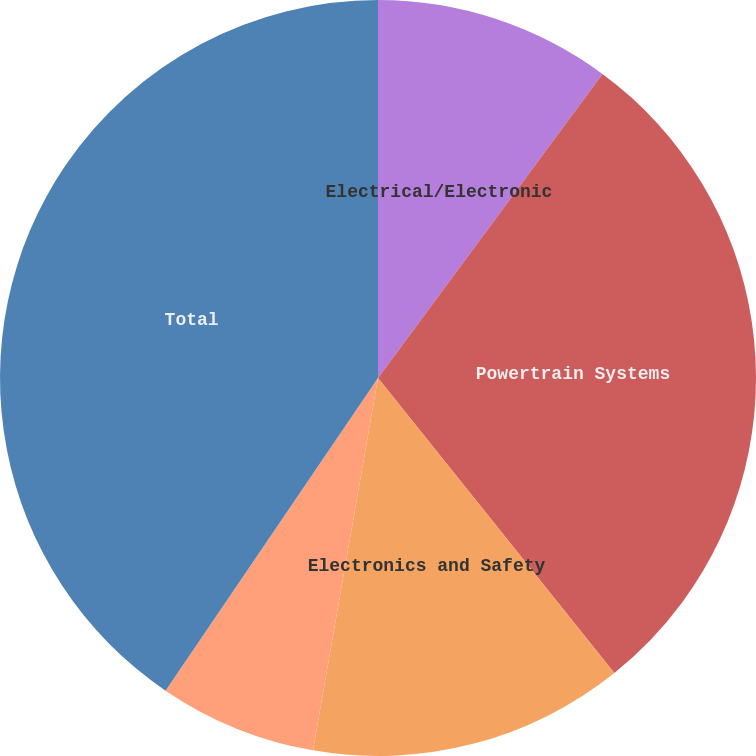Convert chart. <chart><loc_0><loc_0><loc_500><loc_500><pie_chart><fcel>Electrical/Electronic<fcel>Powertrain Systems<fcel>Electronics and Safety<fcel>Thermal Systems<fcel>Total<nl><fcel>10.12%<fcel>29.13%<fcel>13.5%<fcel>6.75%<fcel>40.5%<nl></chart> 